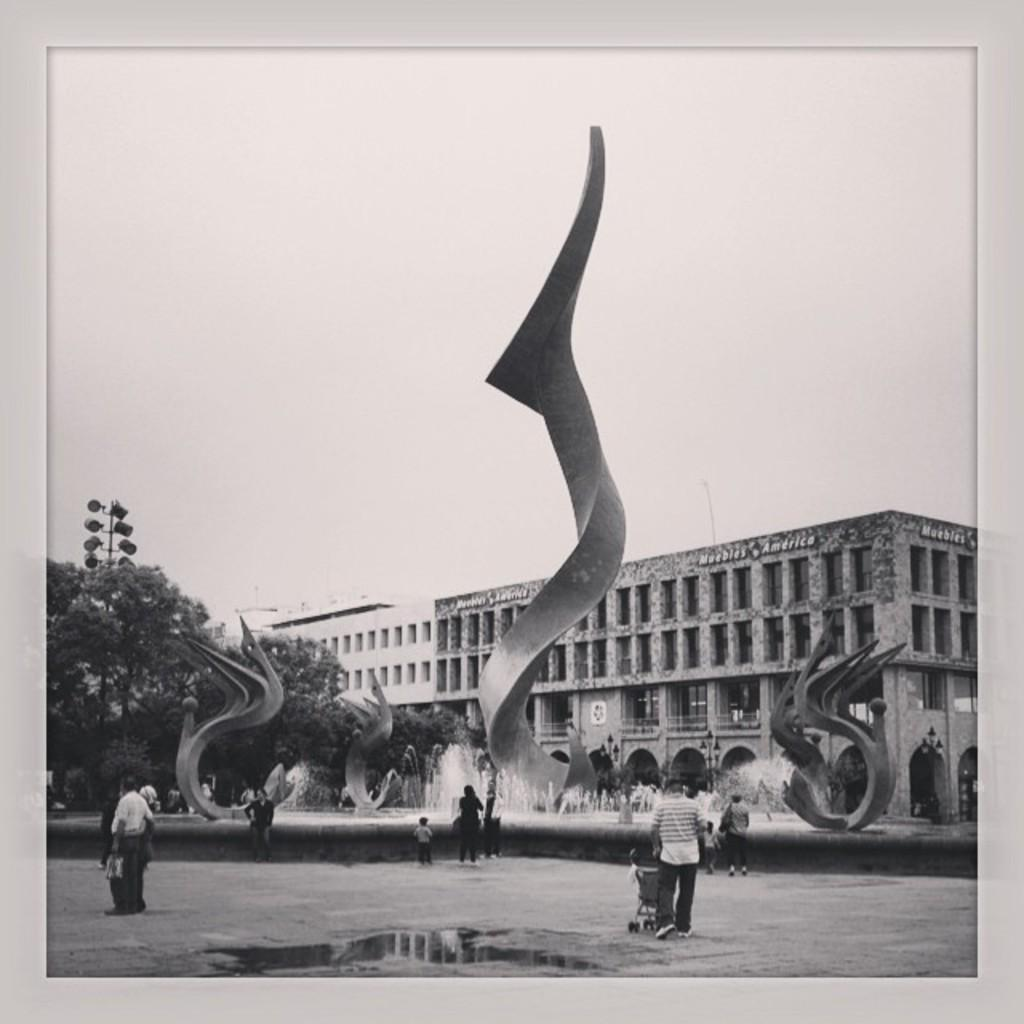What is happening on the road in the image? There are people on the road in the image. What is a notable feature in the image besides the people? There is a fountain in the image. Are there any other objects or structures in the image? Yes, there are statues, trees, a pole with lights, and a building in the image. What can be seen in the background of the image? The sky is visible in the background of the image. Can you see any ants crawling on the statues in the image? There are no ants visible in the image; the focus is on the people, fountain, statues, trees, pole with lights, building, and sky. Is there any blood visible on the statues in the image? There is no blood present in the image; the statues are clean and unblemished. 